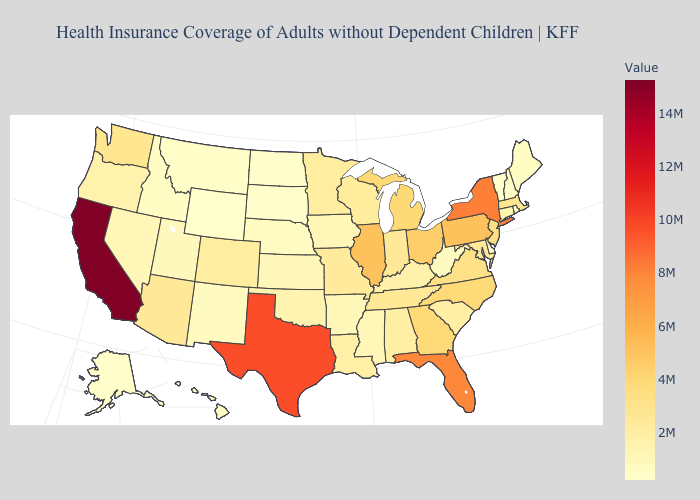Does Arizona have the highest value in the West?
Answer briefly. No. Does Virginia have a lower value than Wyoming?
Keep it brief. No. Which states have the lowest value in the USA?
Short answer required. Wyoming. Among the states that border Wyoming , does Montana have the highest value?
Give a very brief answer. No. Does New Jersey have the lowest value in the USA?
Answer briefly. No. 